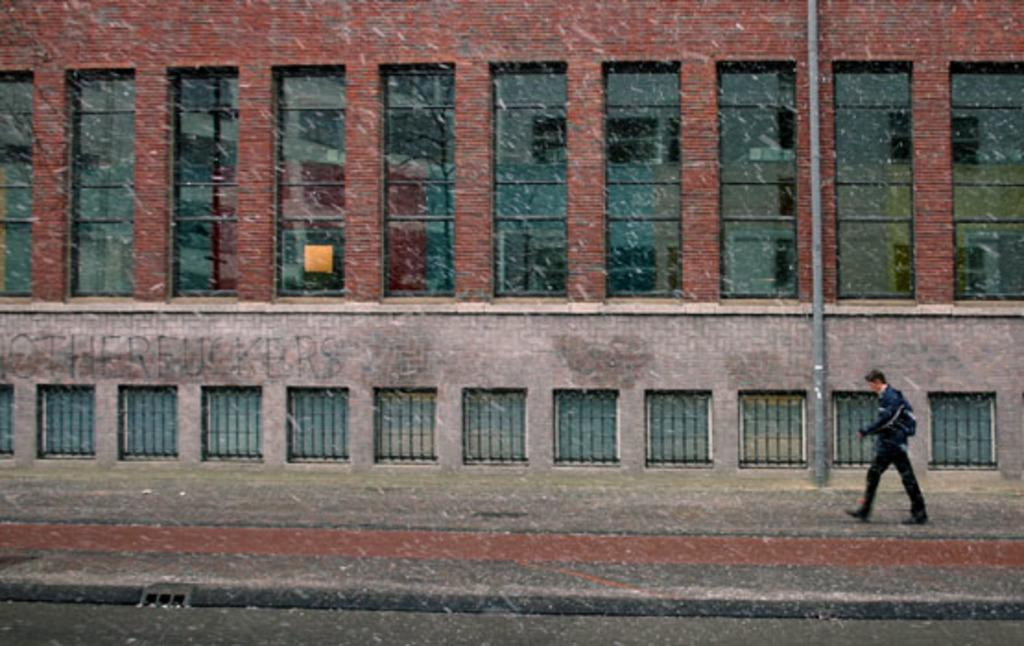What is the main subject of the image? There is a person walking in the image. Where is the person located in the image? The person is in the center of the image. What can be seen in the background of the image? There is a building and a pole in the background of the image. What feature of the building is visible in the image? There are windows visible in the background of the image. What type of table is being used by the person in the image? There is no table present in the image; the person is walking. 